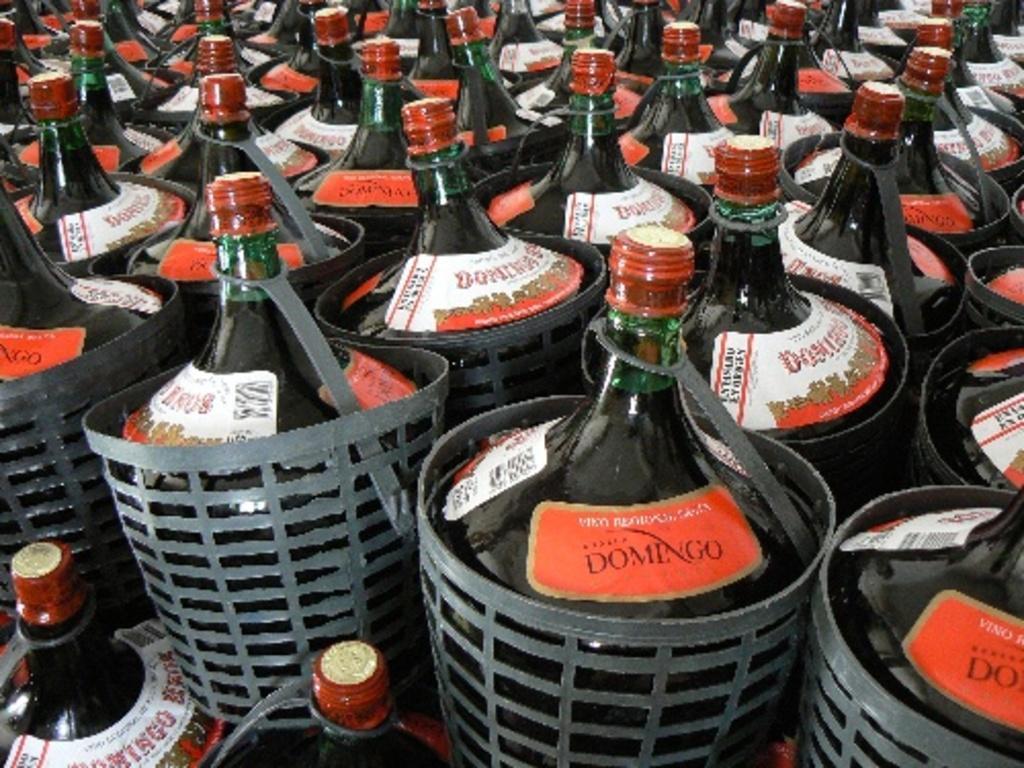Describe this image in one or two sentences. there are lot of bottles on a plastic jars. 